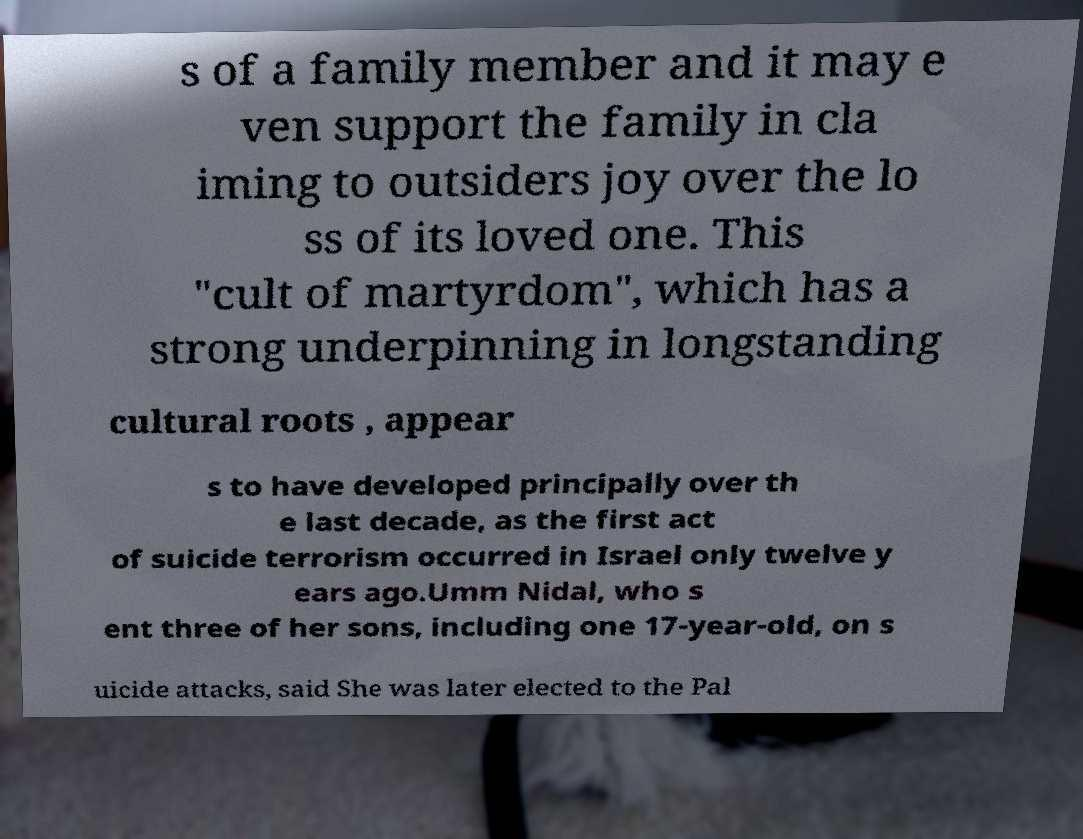For documentation purposes, I need the text within this image transcribed. Could you provide that? s of a family member and it may e ven support the family in cla iming to outsiders joy over the lo ss of its loved one. This "cult of martyrdom", which has a strong underpinning in longstanding cultural roots , appear s to have developed principally over th e last decade, as the first act of suicide terrorism occurred in Israel only twelve y ears ago.Umm Nidal, who s ent three of her sons, including one 17-year-old, on s uicide attacks, said She was later elected to the Pal 